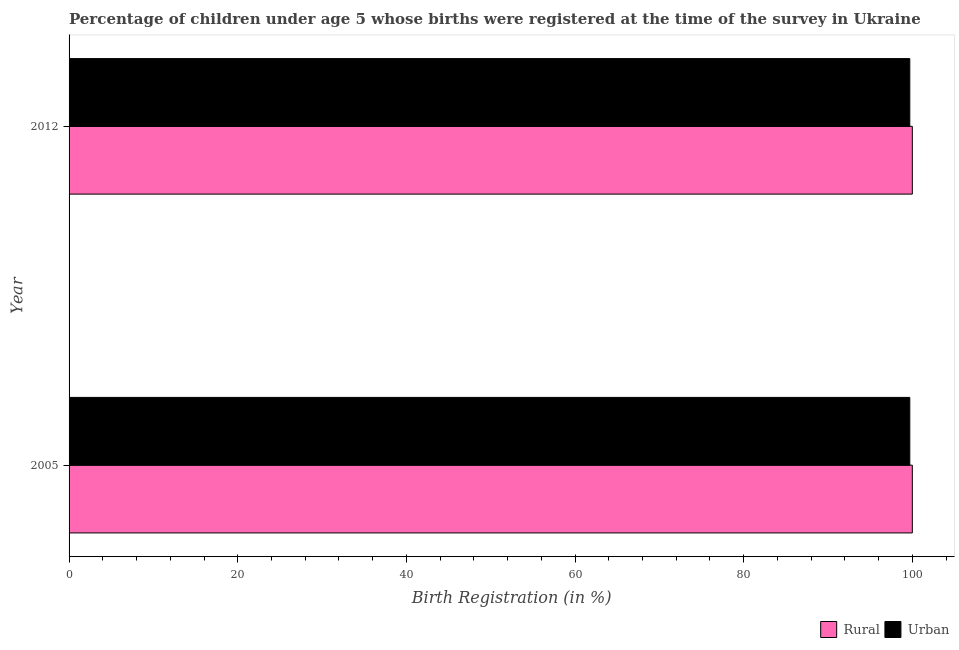How many groups of bars are there?
Make the answer very short. 2. Are the number of bars per tick equal to the number of legend labels?
Your answer should be very brief. Yes. How many bars are there on the 2nd tick from the top?
Keep it short and to the point. 2. What is the label of the 1st group of bars from the top?
Your answer should be very brief. 2012. In how many cases, is the number of bars for a given year not equal to the number of legend labels?
Make the answer very short. 0. What is the rural birth registration in 2005?
Keep it short and to the point. 100. Across all years, what is the maximum urban birth registration?
Your answer should be very brief. 99.7. Across all years, what is the minimum urban birth registration?
Ensure brevity in your answer.  99.7. In which year was the rural birth registration minimum?
Your answer should be compact. 2005. What is the total rural birth registration in the graph?
Your answer should be compact. 200. What is the difference between the rural birth registration in 2005 and the urban birth registration in 2012?
Keep it short and to the point. 0.3. What is the average urban birth registration per year?
Offer a terse response. 99.7. What is the ratio of the rural birth registration in 2005 to that in 2012?
Offer a very short reply. 1. Is the rural birth registration in 2005 less than that in 2012?
Offer a terse response. No. Is the difference between the urban birth registration in 2005 and 2012 greater than the difference between the rural birth registration in 2005 and 2012?
Your response must be concise. No. In how many years, is the rural birth registration greater than the average rural birth registration taken over all years?
Keep it short and to the point. 0. What does the 2nd bar from the top in 2012 represents?
Your response must be concise. Rural. What does the 1st bar from the bottom in 2012 represents?
Your answer should be compact. Rural. Are all the bars in the graph horizontal?
Your response must be concise. Yes. Are the values on the major ticks of X-axis written in scientific E-notation?
Provide a short and direct response. No. Does the graph contain any zero values?
Your answer should be compact. No. Does the graph contain grids?
Offer a very short reply. No. How many legend labels are there?
Ensure brevity in your answer.  2. How are the legend labels stacked?
Ensure brevity in your answer.  Horizontal. What is the title of the graph?
Provide a short and direct response. Percentage of children under age 5 whose births were registered at the time of the survey in Ukraine. What is the label or title of the X-axis?
Provide a short and direct response. Birth Registration (in %). What is the label or title of the Y-axis?
Your answer should be compact. Year. What is the Birth Registration (in %) of Urban in 2005?
Make the answer very short. 99.7. What is the Birth Registration (in %) of Urban in 2012?
Give a very brief answer. 99.7. Across all years, what is the maximum Birth Registration (in %) of Urban?
Provide a succinct answer. 99.7. Across all years, what is the minimum Birth Registration (in %) of Urban?
Make the answer very short. 99.7. What is the total Birth Registration (in %) in Rural in the graph?
Provide a short and direct response. 200. What is the total Birth Registration (in %) in Urban in the graph?
Offer a very short reply. 199.4. What is the difference between the Birth Registration (in %) of Rural in 2005 and that in 2012?
Ensure brevity in your answer.  0. What is the difference between the Birth Registration (in %) in Rural in 2005 and the Birth Registration (in %) in Urban in 2012?
Your response must be concise. 0.3. What is the average Birth Registration (in %) in Rural per year?
Make the answer very short. 100. What is the average Birth Registration (in %) of Urban per year?
Ensure brevity in your answer.  99.7. In the year 2012, what is the difference between the Birth Registration (in %) of Rural and Birth Registration (in %) of Urban?
Your answer should be compact. 0.3. What is the difference between the highest and the second highest Birth Registration (in %) of Rural?
Offer a very short reply. 0. What is the difference between the highest and the lowest Birth Registration (in %) of Rural?
Ensure brevity in your answer.  0. 